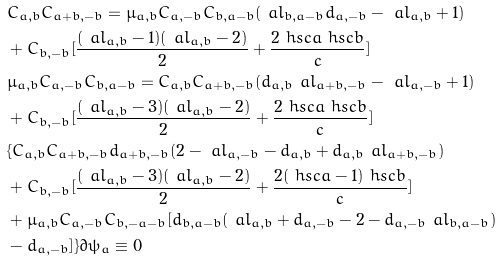Convert formula to latex. <formula><loc_0><loc_0><loc_500><loc_500>& C _ { a , b } C _ { a + b , - b } = \mu _ { a , b } C _ { a , - b } C _ { b , a - b } ( \ a l _ { b , a - b } d _ { a , - b } - \ a l _ { a , b } + 1 ) \\ & + C _ { b , - b } [ \frac { ( \ a l _ { a , b } - 1 ) ( \ a l _ { a , b } - 2 ) } { 2 } + \frac { 2 \ h s c { a } \ h s c { b } } { c } ] \\ & \mu _ { a , b } C _ { a , - b } C _ { b , a - b } = C _ { a , b } C _ { a + b , - b } ( d _ { a , b } \ a l _ { a + b , - b } - \ a l _ { a , - b } + 1 ) \\ & + C _ { b , - b } [ \frac { ( \ a l _ { a , b } - 3 ) ( \ a l _ { a , b } - 2 ) } { 2 } + \frac { 2 \ h s c { a } \ h s c { b } } { c } ] \\ & \{ C _ { a , b } C _ { a + b , - b } d _ { a + b , - b } ( 2 - \ a l _ { a , - b } - d _ { a , b } + d _ { a , b } \ a l _ { a + b , - b } ) \\ & + C _ { b , - b } [ \frac { ( \ a l _ { a , b } - 3 ) ( \ a l _ { a , b } - 2 ) } { 2 } + \frac { 2 ( \ h s c { a } - 1 ) \ h s c { b } } { c } ] \\ & + \mu _ { a , b } C _ { a , - b } C _ { b , - a - b } [ d _ { b , a - b } ( \ a l _ { a , b } + d _ { a , - b } - 2 - d _ { a , - b } \ a l _ { b , a - b } ) \\ & - d _ { a , - b } ] \} \partial \psi _ { a } \equiv 0</formula> 